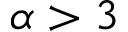Convert formula to latex. <formula><loc_0><loc_0><loc_500><loc_500>\alpha > 3</formula> 